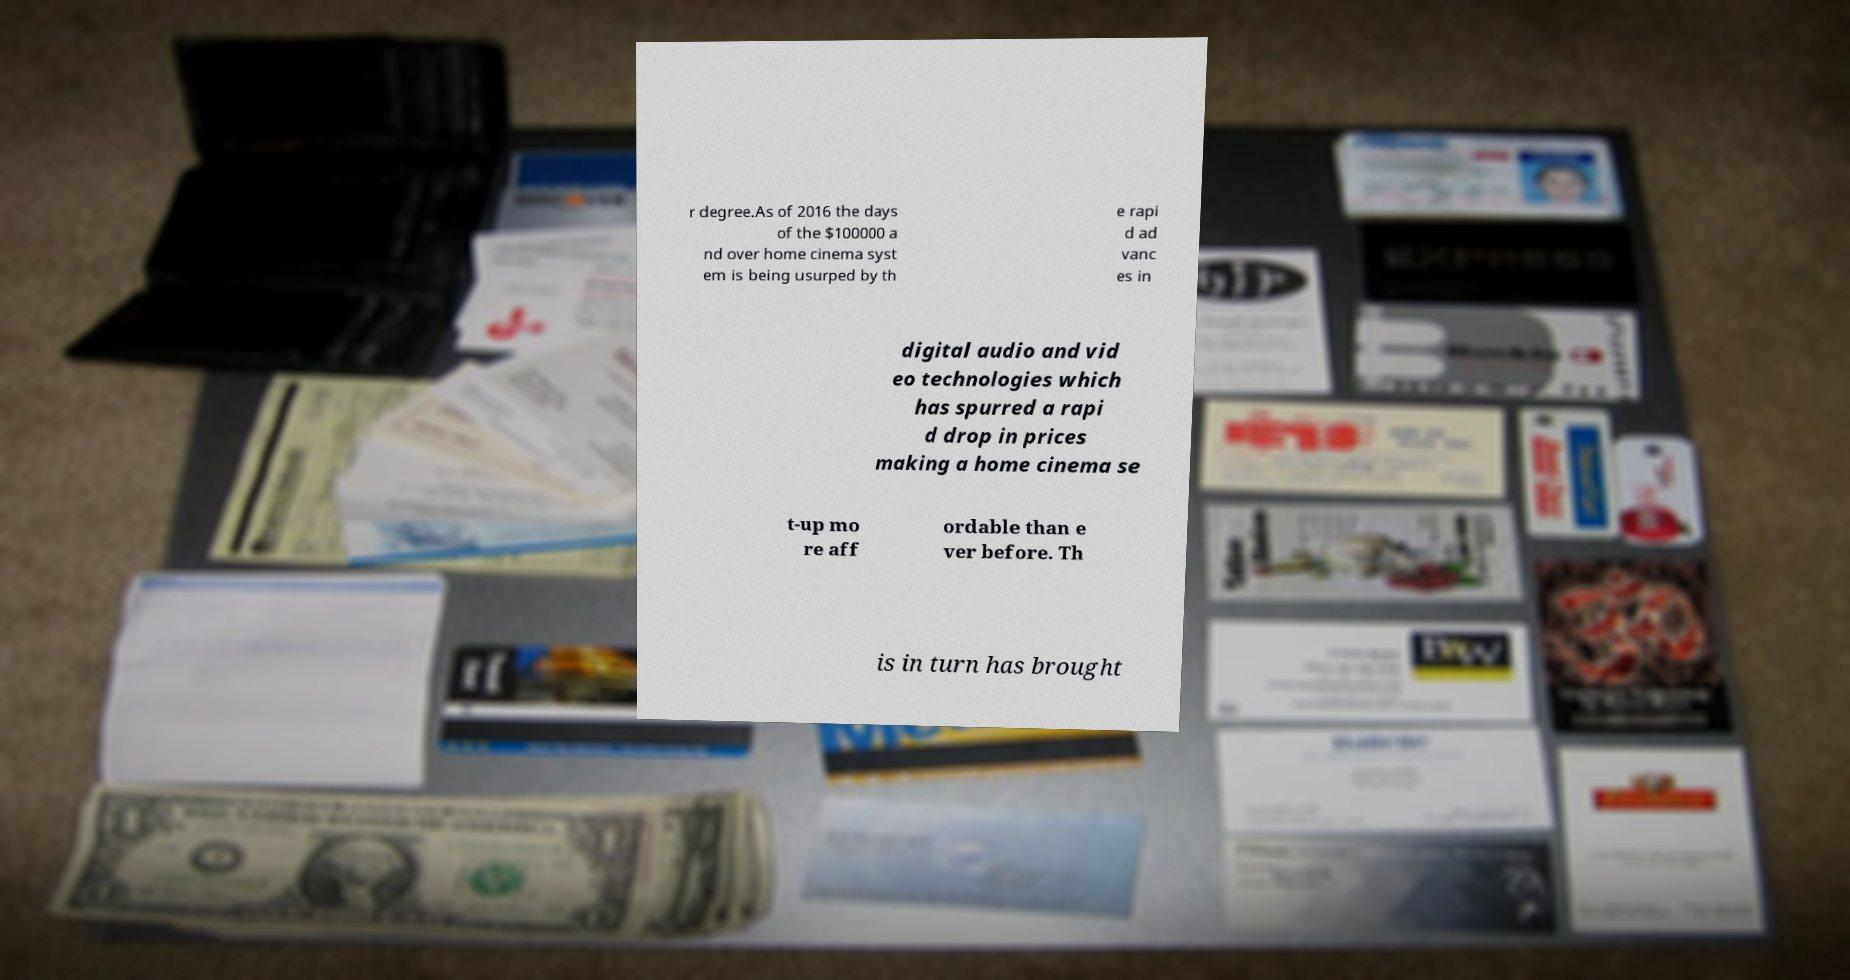Can you read and provide the text displayed in the image?This photo seems to have some interesting text. Can you extract and type it out for me? r degree.As of 2016 the days of the $100000 a nd over home cinema syst em is being usurped by th e rapi d ad vanc es in digital audio and vid eo technologies which has spurred a rapi d drop in prices making a home cinema se t-up mo re aff ordable than e ver before. Th is in turn has brought 